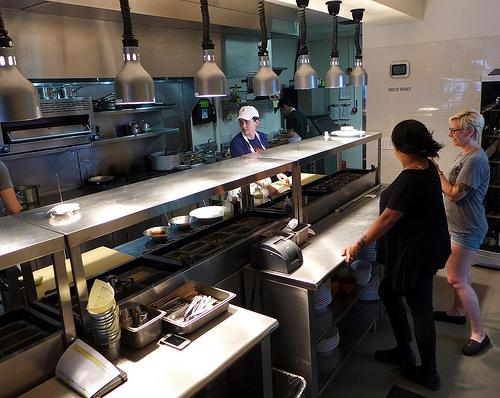Question: where was this taken?
Choices:
A. At a circus.
B. In a restaurant.
C. On a rollercoaster.
D. Underwater.
Answer with the letter. Answer: B Question: why are there people in the kitchen?
Choices:
A. Drinking.
B. Talking about the day.
C. Eating cheese sticks.
D. They are cooking.
Answer with the letter. Answer: D Question: who is the man in the black t-shirt in the kitchen?
Choices:
A. The dish washer.
B. A food preparer.
C. The manager.
D. An irate customer.
Answer with the letter. Answer: B Question: what are the two women waiting for?
Choices:
A. Their food.
B. The bus.
C. The movie to start.
D. The parade float.
Answer with the letter. Answer: A Question: how many people are in the kitchen?
Choices:
A. Four.
B. Five.
C. Three.
D. Six.
Answer with the letter. Answer: C 